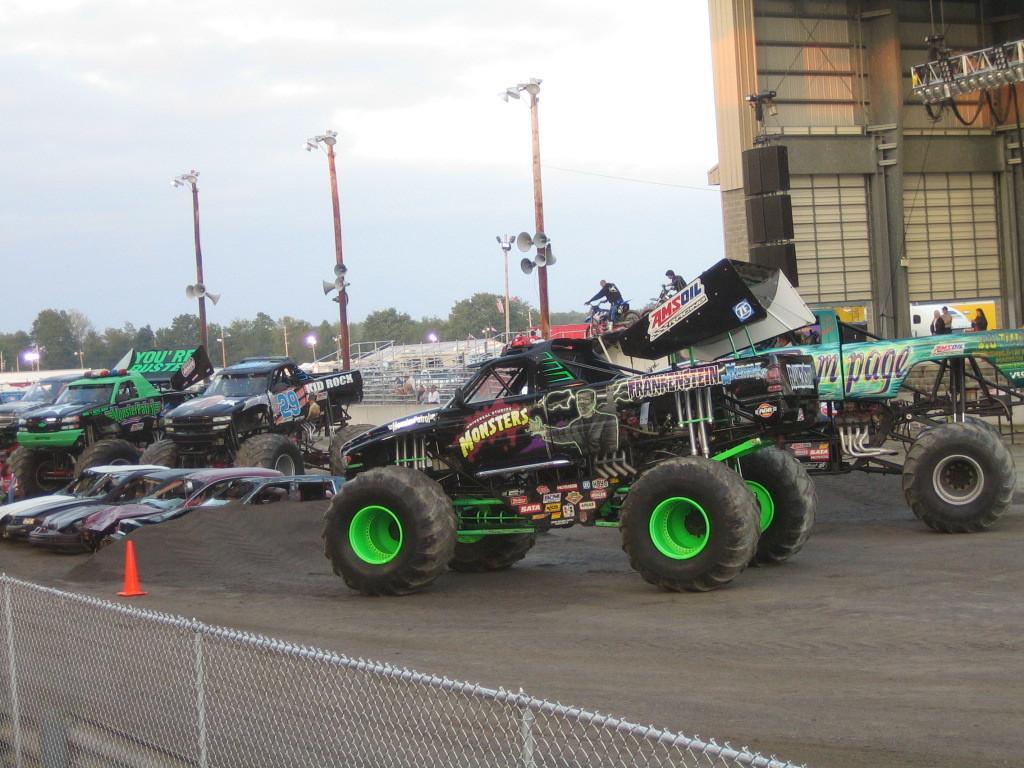Can you describe this image briefly? This picture is clicked outside. In the foreground we can see the mesh and the metal rods. In the center we can see the monster trucks placed on the ground and there are some vehicles parked on the ground. In the background we can see the sky, building, metal rods, lights, poles, trees and some other objects. 